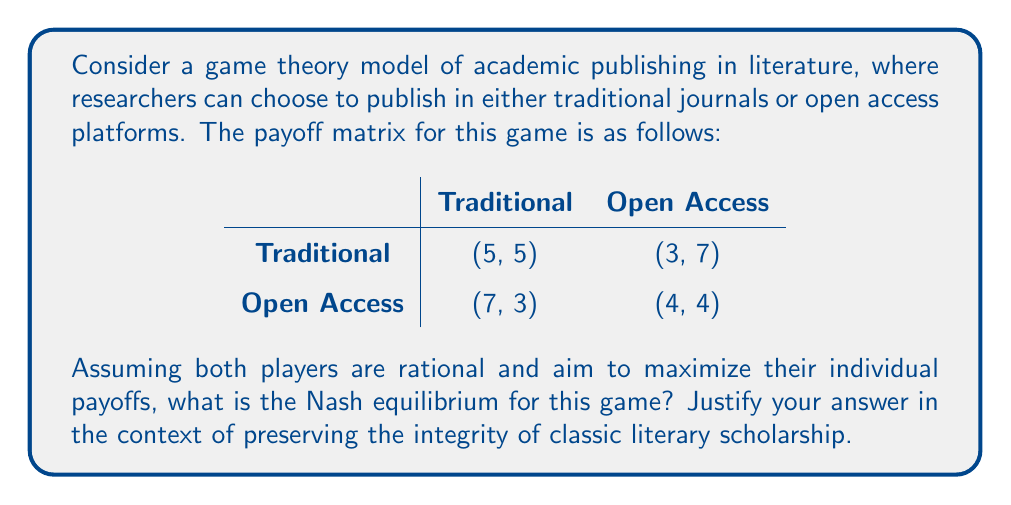Help me with this question. To solve this game theory problem, we need to follow these steps:

1. Identify the dominant strategies for each player:
   - For Player 1 (row):
     - If Player 2 chooses Traditional: 7 > 5, so Open Access is better
     - If Player 2 chooses Open Access: 4 > 3, so Open Access is better
   - For Player 2 (column):
     - If Player 1 chooses Traditional: 7 > 5, so Open Access is better
     - If Player 1 chooses Open Access: 4 > 3, so Open Access is better

2. Determine the Nash equilibrium:
   Since both players have Open Access as their dominant strategy, the Nash equilibrium is (Open Access, Open Access) with payoffs (4, 4).

3. Interpret the result:
   This equilibrium suggests that rational players would choose Open Access publishing, despite the potential for higher individual payoffs if they could coordinate on Traditional publishing (5, 5).

4. Context for literary scholarship:
   From the perspective of a PhD in Literature skeptical about the dilution of classic texts, this equilibrium is concerning. The shift towards Open Access may lead to:
   - Reduced quality control in publishing
   - Fragmentation of scholarly discourse
   - Potential loss of prestige associated with traditional publishing venues

   However, the model also shows that unilateral adherence to traditional publishing (3, 7) or (7, 3) is individually suboptimal, highlighting the collective action problem faced by scholars in preserving traditional publishing norms.
Answer: Nash equilibrium: (Open Access, Open Access) with payoffs (4, 4) 